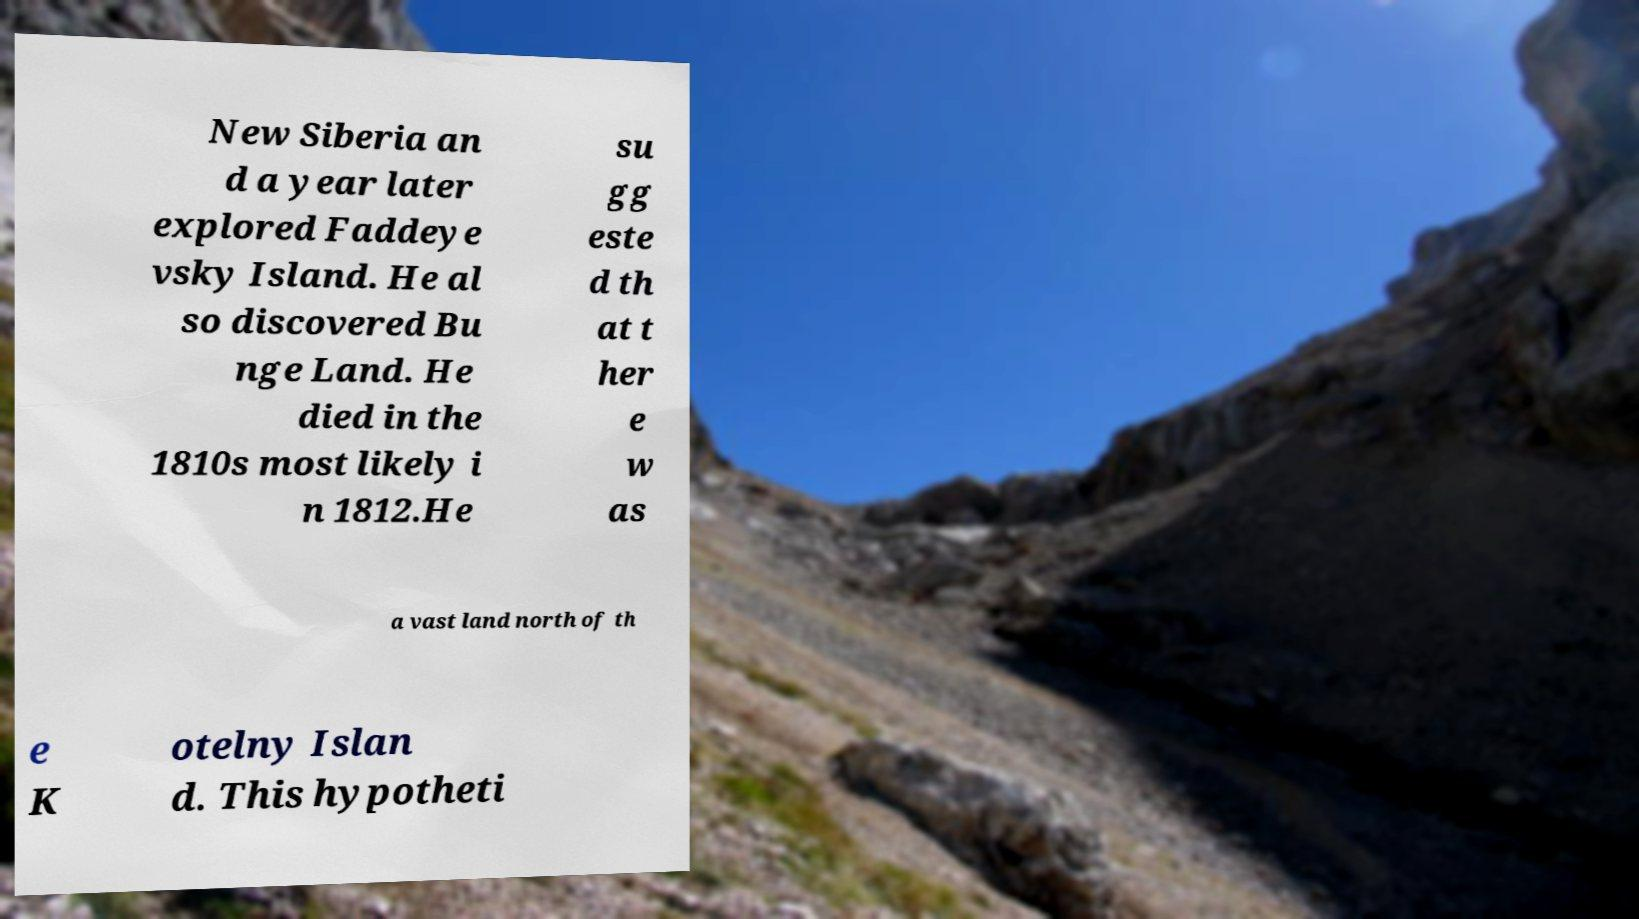Can you accurately transcribe the text from the provided image for me? New Siberia an d a year later explored Faddeye vsky Island. He al so discovered Bu nge Land. He died in the 1810s most likely i n 1812.He su gg este d th at t her e w as a vast land north of th e K otelny Islan d. This hypotheti 